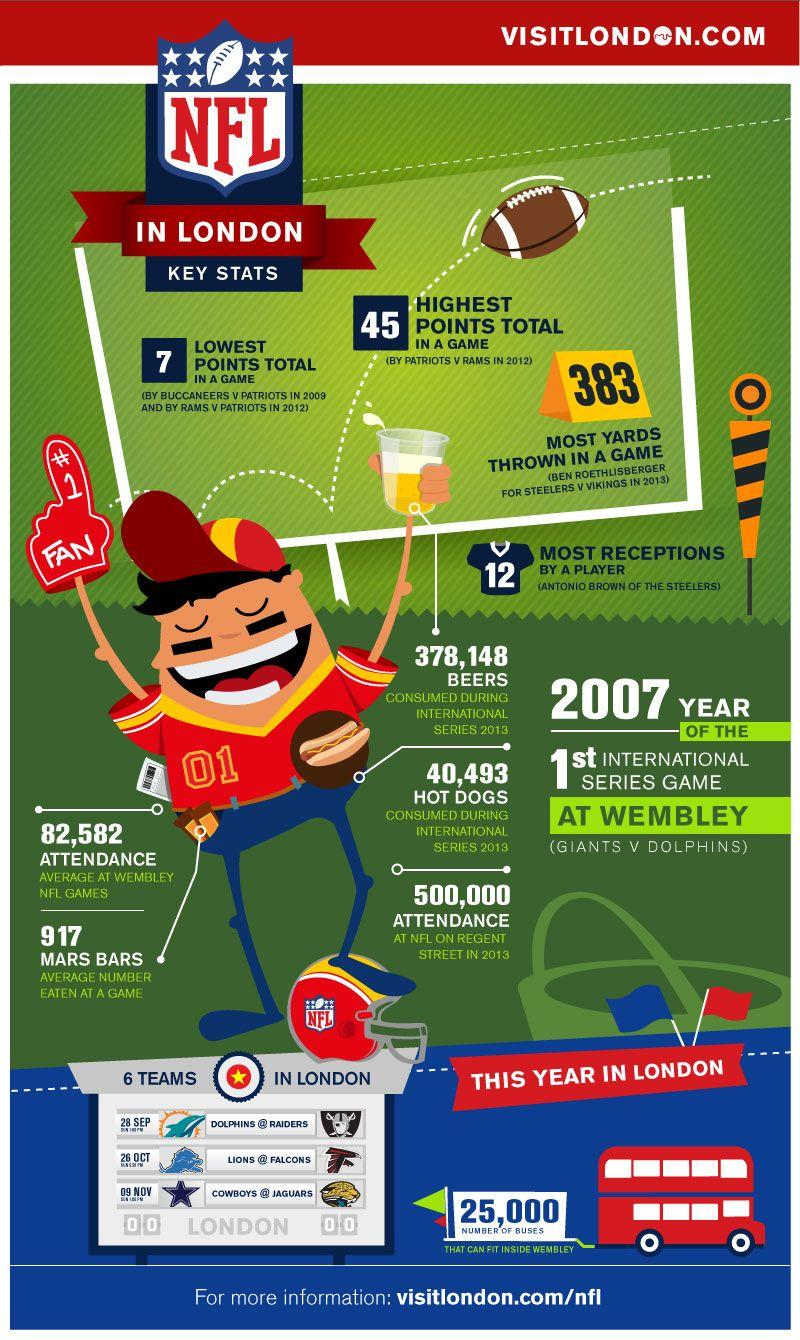Indicate a few pertinent items in this graphic. In 2013, an estimated 500,000 people attended the NFL event that took place on Regent Street. The record for the most receptions made by a player in NFL games in London is 12. Ben Roethlisberger has thrown for the most yards in NFL games played in London in 2013. The National Football League (NFL) began playing international games in 2007. 